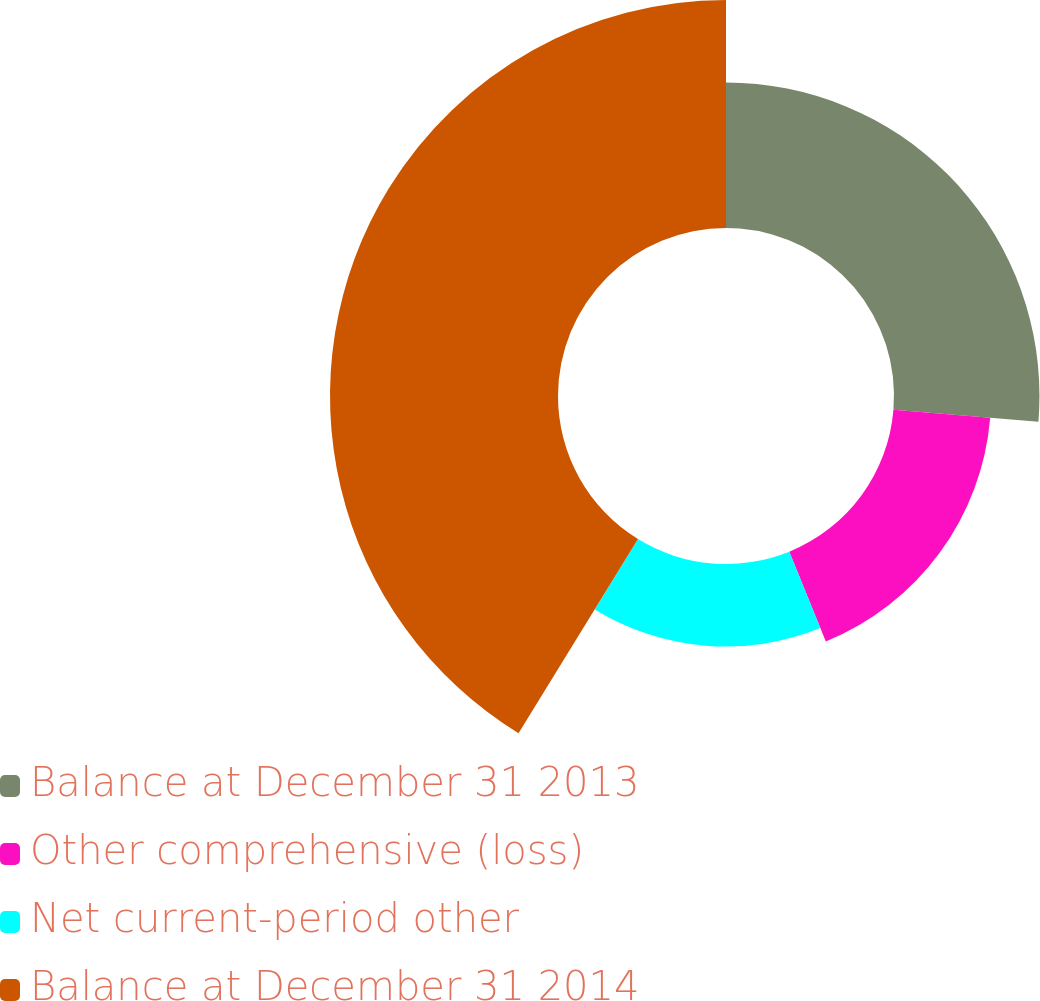Convert chart. <chart><loc_0><loc_0><loc_500><loc_500><pie_chart><fcel>Balance at December 31 2013<fcel>Other comprehensive (loss)<fcel>Net current-period other<fcel>Balance at December 31 2014<nl><fcel>26.3%<fcel>17.55%<fcel>14.92%<fcel>41.22%<nl></chart> 